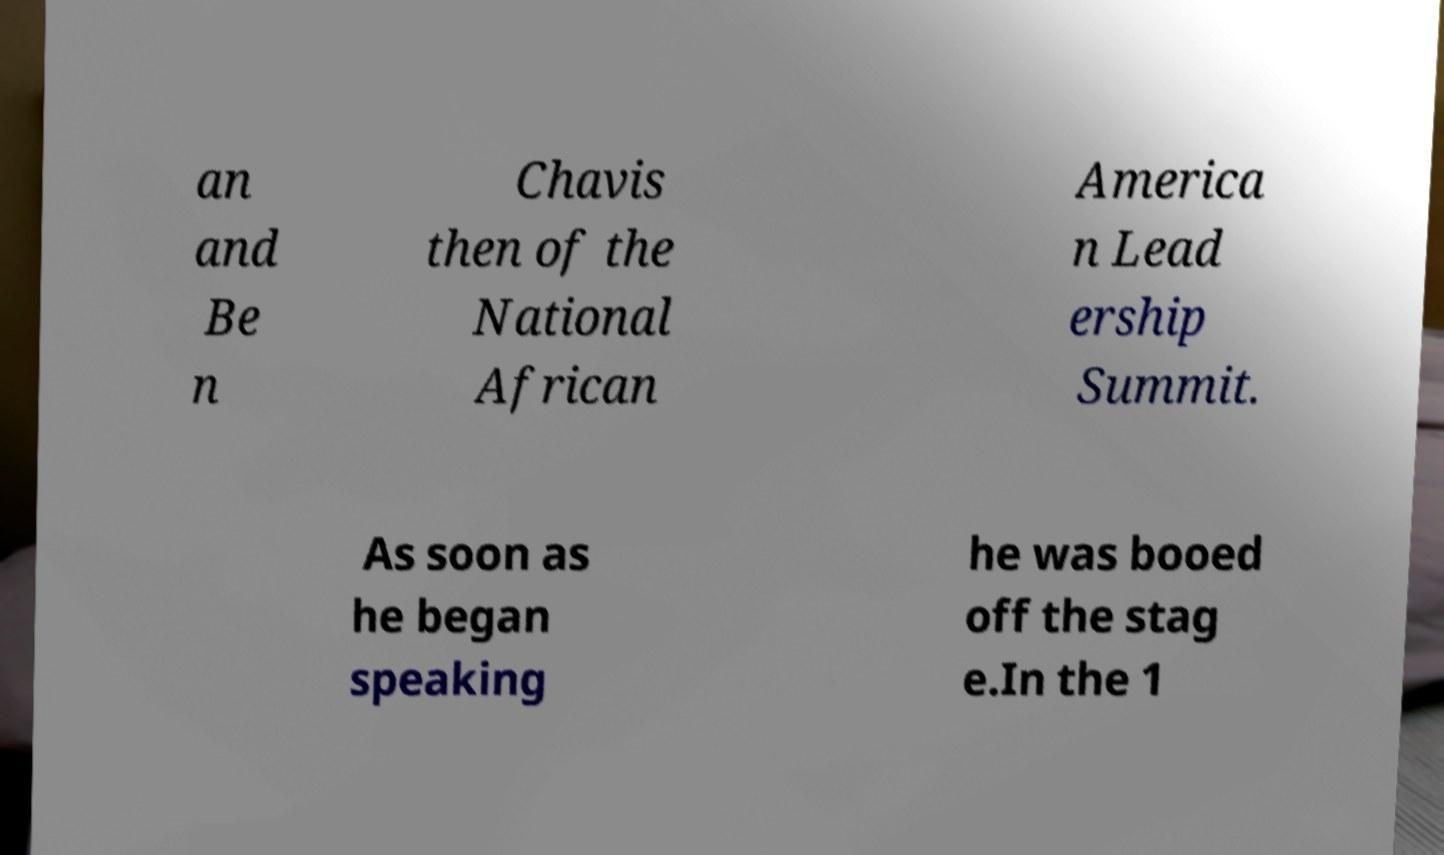Could you assist in decoding the text presented in this image and type it out clearly? an and Be n Chavis then of the National African America n Lead ership Summit. As soon as he began speaking he was booed off the stag e.In the 1 